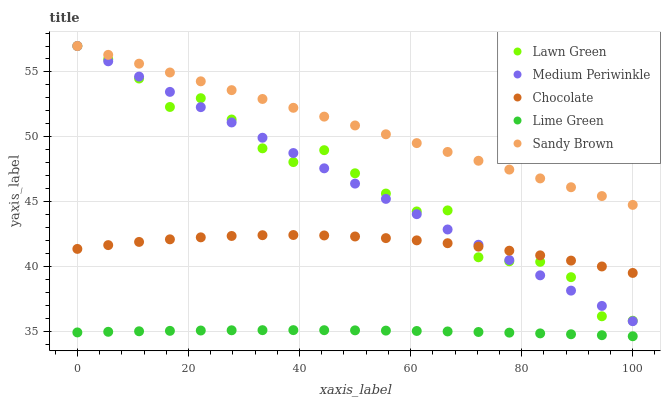Does Lime Green have the minimum area under the curve?
Answer yes or no. Yes. Does Sandy Brown have the maximum area under the curve?
Answer yes or no. Yes. Does Medium Periwinkle have the minimum area under the curve?
Answer yes or no. No. Does Medium Periwinkle have the maximum area under the curve?
Answer yes or no. No. Is Sandy Brown the smoothest?
Answer yes or no. Yes. Is Lawn Green the roughest?
Answer yes or no. Yes. Is Medium Periwinkle the smoothest?
Answer yes or no. No. Is Medium Periwinkle the roughest?
Answer yes or no. No. Does Lime Green have the lowest value?
Answer yes or no. Yes. Does Medium Periwinkle have the lowest value?
Answer yes or no. No. Does Sandy Brown have the highest value?
Answer yes or no. Yes. Does Lime Green have the highest value?
Answer yes or no. No. Is Lime Green less than Chocolate?
Answer yes or no. Yes. Is Chocolate greater than Lime Green?
Answer yes or no. Yes. Does Medium Periwinkle intersect Sandy Brown?
Answer yes or no. Yes. Is Medium Periwinkle less than Sandy Brown?
Answer yes or no. No. Is Medium Periwinkle greater than Sandy Brown?
Answer yes or no. No. Does Lime Green intersect Chocolate?
Answer yes or no. No. 